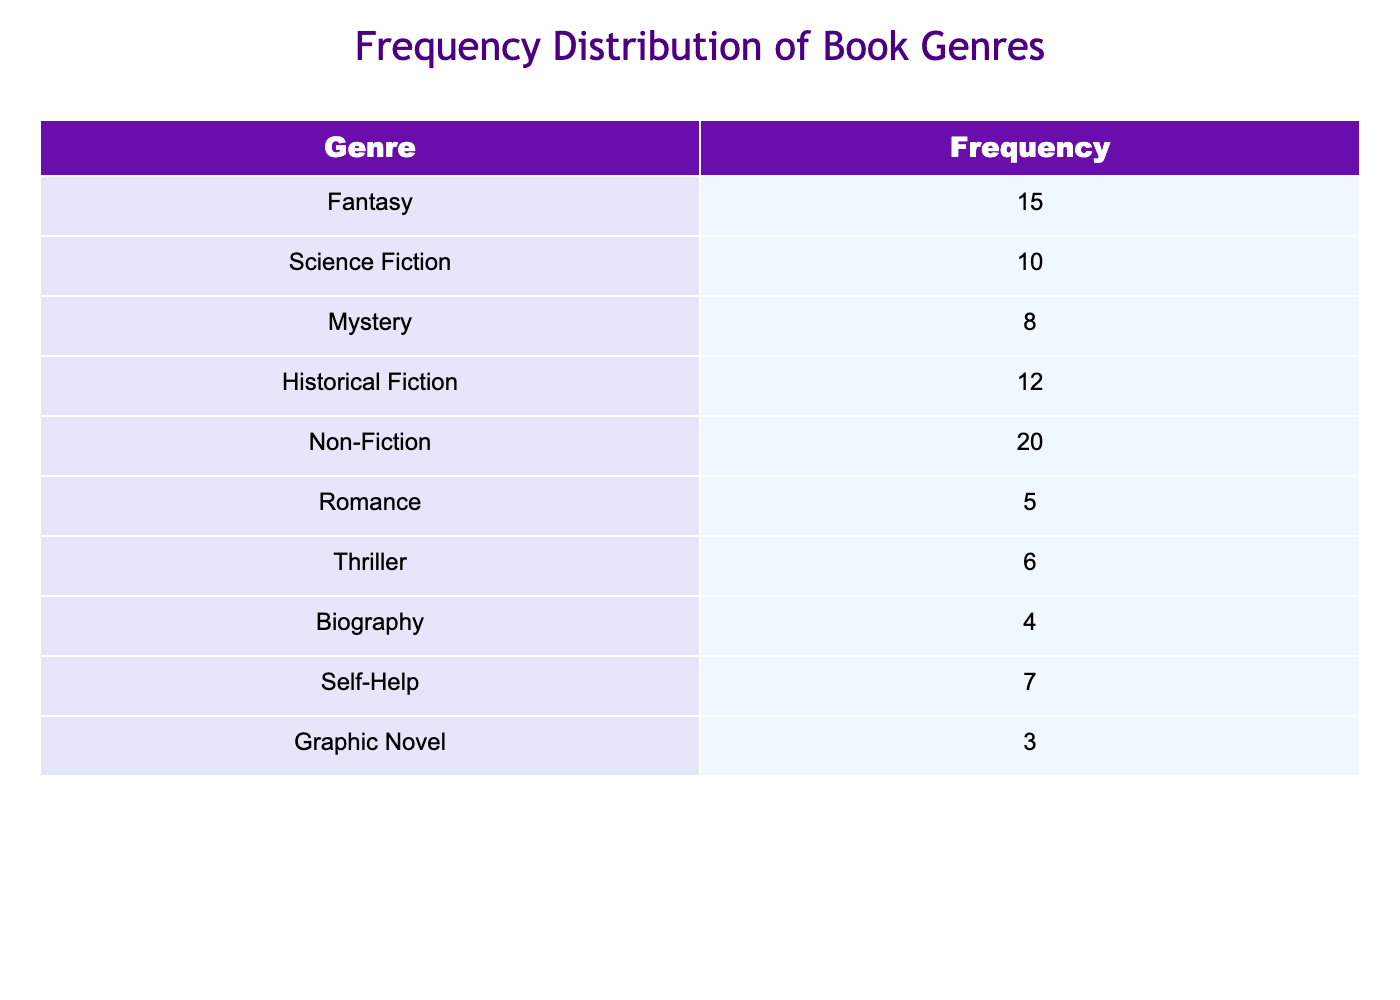What is the frequency of the Non-Fiction genre? The table lists different genres and their frequencies. The frequency for Non-Fiction is directly stated in the table.
Answer: 20 Which genre has the highest frequency? By examining the frequencies listed for each genre, it's clear that Non-Fiction has the highest frequency, at 20.
Answer: Non-Fiction What is the total frequency of genres that fall under Fiction (Fantasy, Science Fiction, Mystery, Historical Fiction, and Romance)? To find the total, we add the frequencies of all fiction genres: 15 (Fantasy) + 10 (Science Fiction) + 8 (Mystery) + 12 (Historical Fiction) + 5 (Romance) = 50.
Answer: 50 Is there a genre with a frequency of more than 15? Looking at the frequency values, only Non-Fiction (20) and Fantasy (15) are listed. Only Non-Fiction exceeds 15, while Fantasy is exactly 15.
Answer: Yes What is the average frequency of the Thrilling and Biography genres? First, identify the frequencies for both genres: Thriller has 6 and Biography has 4. The average is calculated by (6 + 4) / 2, which equals 5.
Answer: 5 How many genres have a frequency of 8 or less? The frequencies listed are: 3 (Graphic Novel), 4 (Biography), 5 (Romance), 6 (Thriller), and 8 (Mystery). We can count these genres which total 5.
Answer: 5 What is the difference between the frequency of Non-Fiction and Romance? Non-Fiction has a frequency of 20, and Romance has a frequency of 5. Calculating the difference: 20 - 5 = 15.
Answer: 15 If we combine the frequencies of Science Fiction and Mystery, what is the total? Science Fiction has a frequency of 10, and Mystery has a frequency of 8. Adding these together gives us 10 + 8 = 18.
Answer: 18 Which genre has the lowest frequency, and what is that frequency? By reviewing the table, Graphic Novel has the lowest frequency listed at 3.
Answer: Graphic Novel, 3 